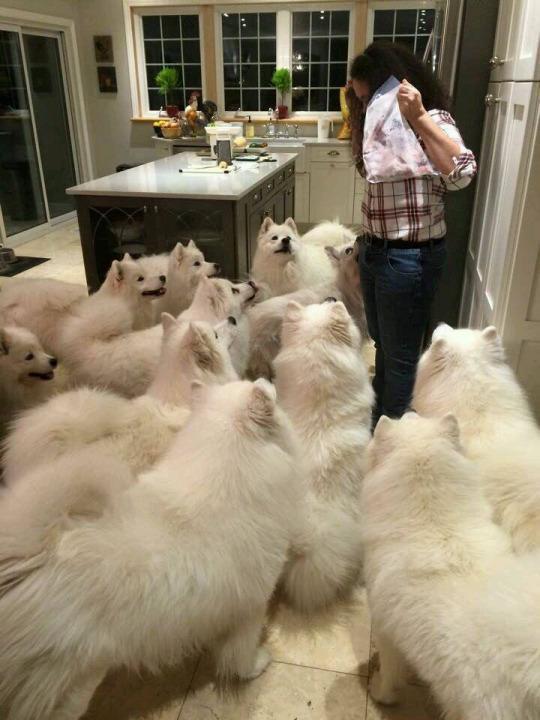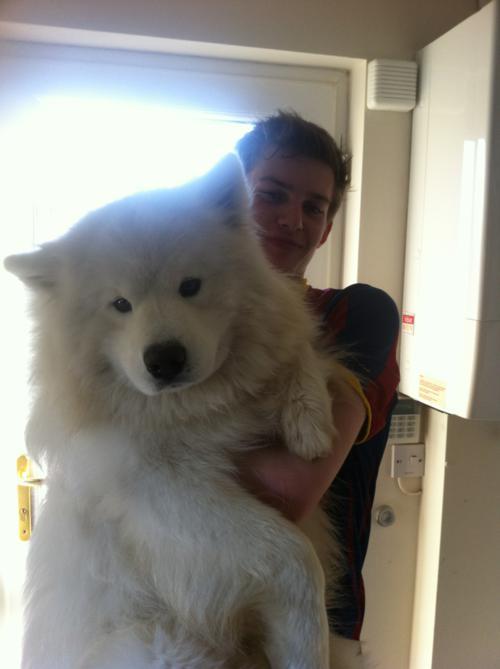The first image is the image on the left, the second image is the image on the right. Examine the images to the left and right. Is the description "One image contains multiple white dog figures, and the other image shows one white dog held up by a human arm." accurate? Answer yes or no. Yes. The first image is the image on the left, the second image is the image on the right. Given the left and right images, does the statement "there is grass visible behind a white dog." hold true? Answer yes or no. No. 